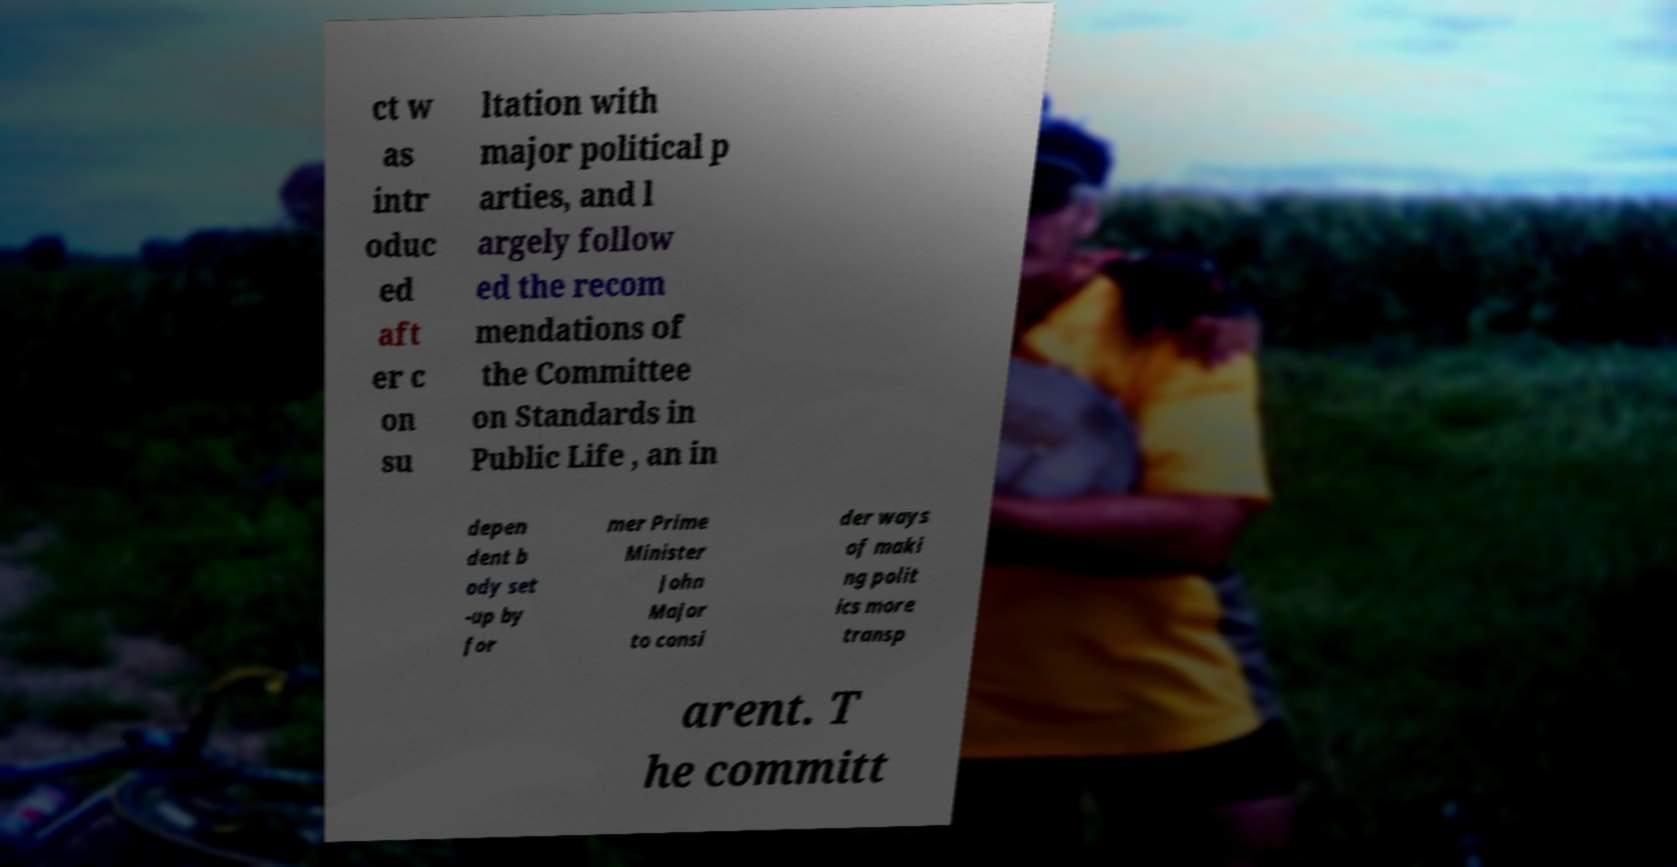For documentation purposes, I need the text within this image transcribed. Could you provide that? ct w as intr oduc ed aft er c on su ltation with major political p arties, and l argely follow ed the recom mendations of the Committee on Standards in Public Life , an in depen dent b ody set -up by for mer Prime Minister John Major to consi der ways of maki ng polit ics more transp arent. T he committ 